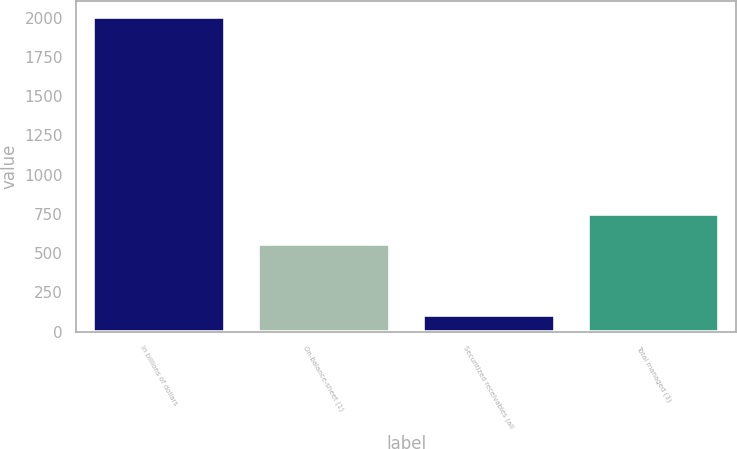Convert chart to OTSL. <chart><loc_0><loc_0><loc_500><loc_500><bar_chart><fcel>In billions of dollars<fcel>On-balance-sheet (1)<fcel>Securitized receivables (all<fcel>Total managed (3)<nl><fcel>2007<fcel>557.8<fcel>108.1<fcel>747.69<nl></chart> 